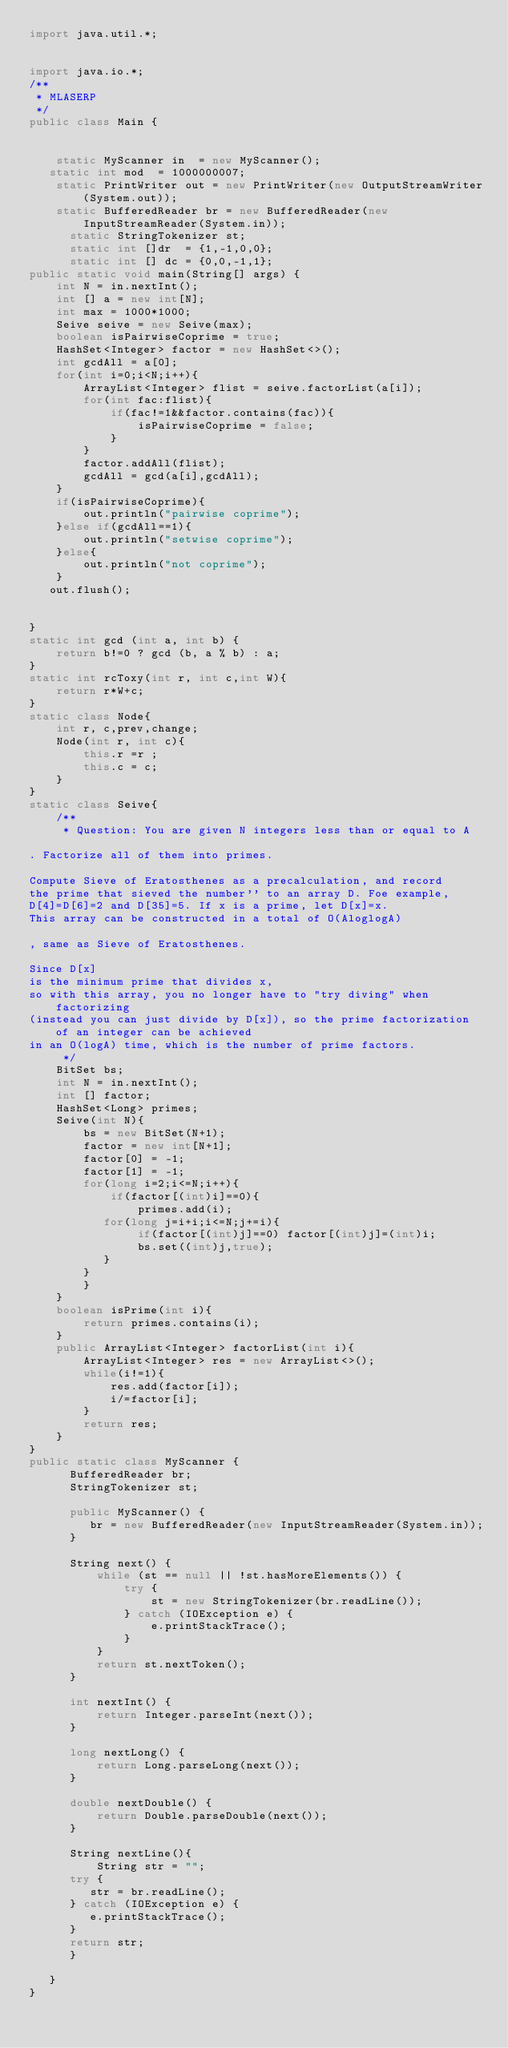Convert code to text. <code><loc_0><loc_0><loc_500><loc_500><_Java_>import java.util.*;


import java.io.*;
/**
 * MLASERP
 */
public class Main {

    
    static MyScanner in  = new MyScanner();
   static int mod  = 1000000007;
    static PrintWriter out = new PrintWriter(new OutputStreamWriter(System.out));
    static BufferedReader br = new BufferedReader(new InputStreamReader(System.in));
      static StringTokenizer st;
      static int []dr  = {1,-1,0,0};
      static int [] dc = {0,0,-1,1};
public static void main(String[] args) {
    int N = in.nextInt();
    int [] a = new int[N];
    int max = 1000*1000;
    Seive seive = new Seive(max);
    boolean isPairwiseCoprime = true;
    HashSet<Integer> factor = new HashSet<>();
    int gcdAll = a[0];
    for(int i=0;i<N;i++){
        ArrayList<Integer> flist = seive.factorList(a[i]);
        for(int fac:flist){
            if(fac!=1&&factor.contains(fac)){
                isPairwiseCoprime = false;
            }
        }
        factor.addAll(flist);
        gcdAll = gcd(a[i],gcdAll);
    }
    if(isPairwiseCoprime){
        out.println("pairwise coprime");
    }else if(gcdAll==1){
        out.println("setwise coprime");
    }else{
        out.println("not coprime");
    }
   out.flush();
   

}
static int gcd (int a, int b) {
    return b!=0 ? gcd (b, a % b) : a;
}
static int rcToxy(int r, int c,int W){
    return r*W+c;
}
static class Node{
    int r, c,prev,change;
    Node(int r, int c){
        this.r =r ;
        this.c = c;
    }
}
static class Seive{
    /**
     * Question: You are given N integers less than or equal to A

. Factorize all of them into primes.

Compute Sieve of Eratosthenes as a precalculation, and record
the prime that sieved the number'' to an array D. Foe example, 
D[4]=D[6]=2 and D[35]=5. If x is a prime, let D[x]=x. 
This array can be constructed in a total of O(AloglogA)

, same as Sieve of Eratosthenes.

Since D[x]
is the minimum prime that divides x, 
so with this array, you no longer have to "try diving" when factorizing
(instead you can just divide by D[x]), so the prime factorization of an integer can be achieved 
in an O(logA) time, which is the number of prime factors.
     */
    BitSet bs;
    int N = in.nextInt();
    int [] factor;
    HashSet<Long> primes;
    Seive(int N){
        bs = new BitSet(N+1);
        factor = new int[N+1];
        factor[0] = -1;
        factor[1] = -1;
        for(long i=2;i<=N;i++){
            if(factor[(int)i]==0){
                primes.add(i);
           for(long j=i+i;i<=N;j+=i){
                if(factor[(int)j]==0) factor[(int)j]=(int)i;
                bs.set((int)j,true);
           }
        }
        }
    }
    boolean isPrime(int i){
        return primes.contains(i);
    }
    public ArrayList<Integer> factorList(int i){
        ArrayList<Integer> res = new ArrayList<>();
        while(i!=1){
            res.add(factor[i]);
            i/=factor[i];
        }
        return res;
    }
}
public static class MyScanner {
      BufferedReader br;
      StringTokenizer st;
 
      public MyScanner() {
         br = new BufferedReader(new InputStreamReader(System.in));
      }
 
      String next() {
          while (st == null || !st.hasMoreElements()) {
              try {
                  st = new StringTokenizer(br.readLine());
              } catch (IOException e) {
                  e.printStackTrace();
              }
          }
          return st.nextToken();
      }
 
      int nextInt() {
          return Integer.parseInt(next());
      }
 
      long nextLong() {
          return Long.parseLong(next());
      }
 
      double nextDouble() {
          return Double.parseDouble(next());
      }
 
      String nextLine(){
          String str = "";
	  try {
	     str = br.readLine();
	  } catch (IOException e) {
	     e.printStackTrace();
	  }
	  return str;
      }

   }
}</code> 